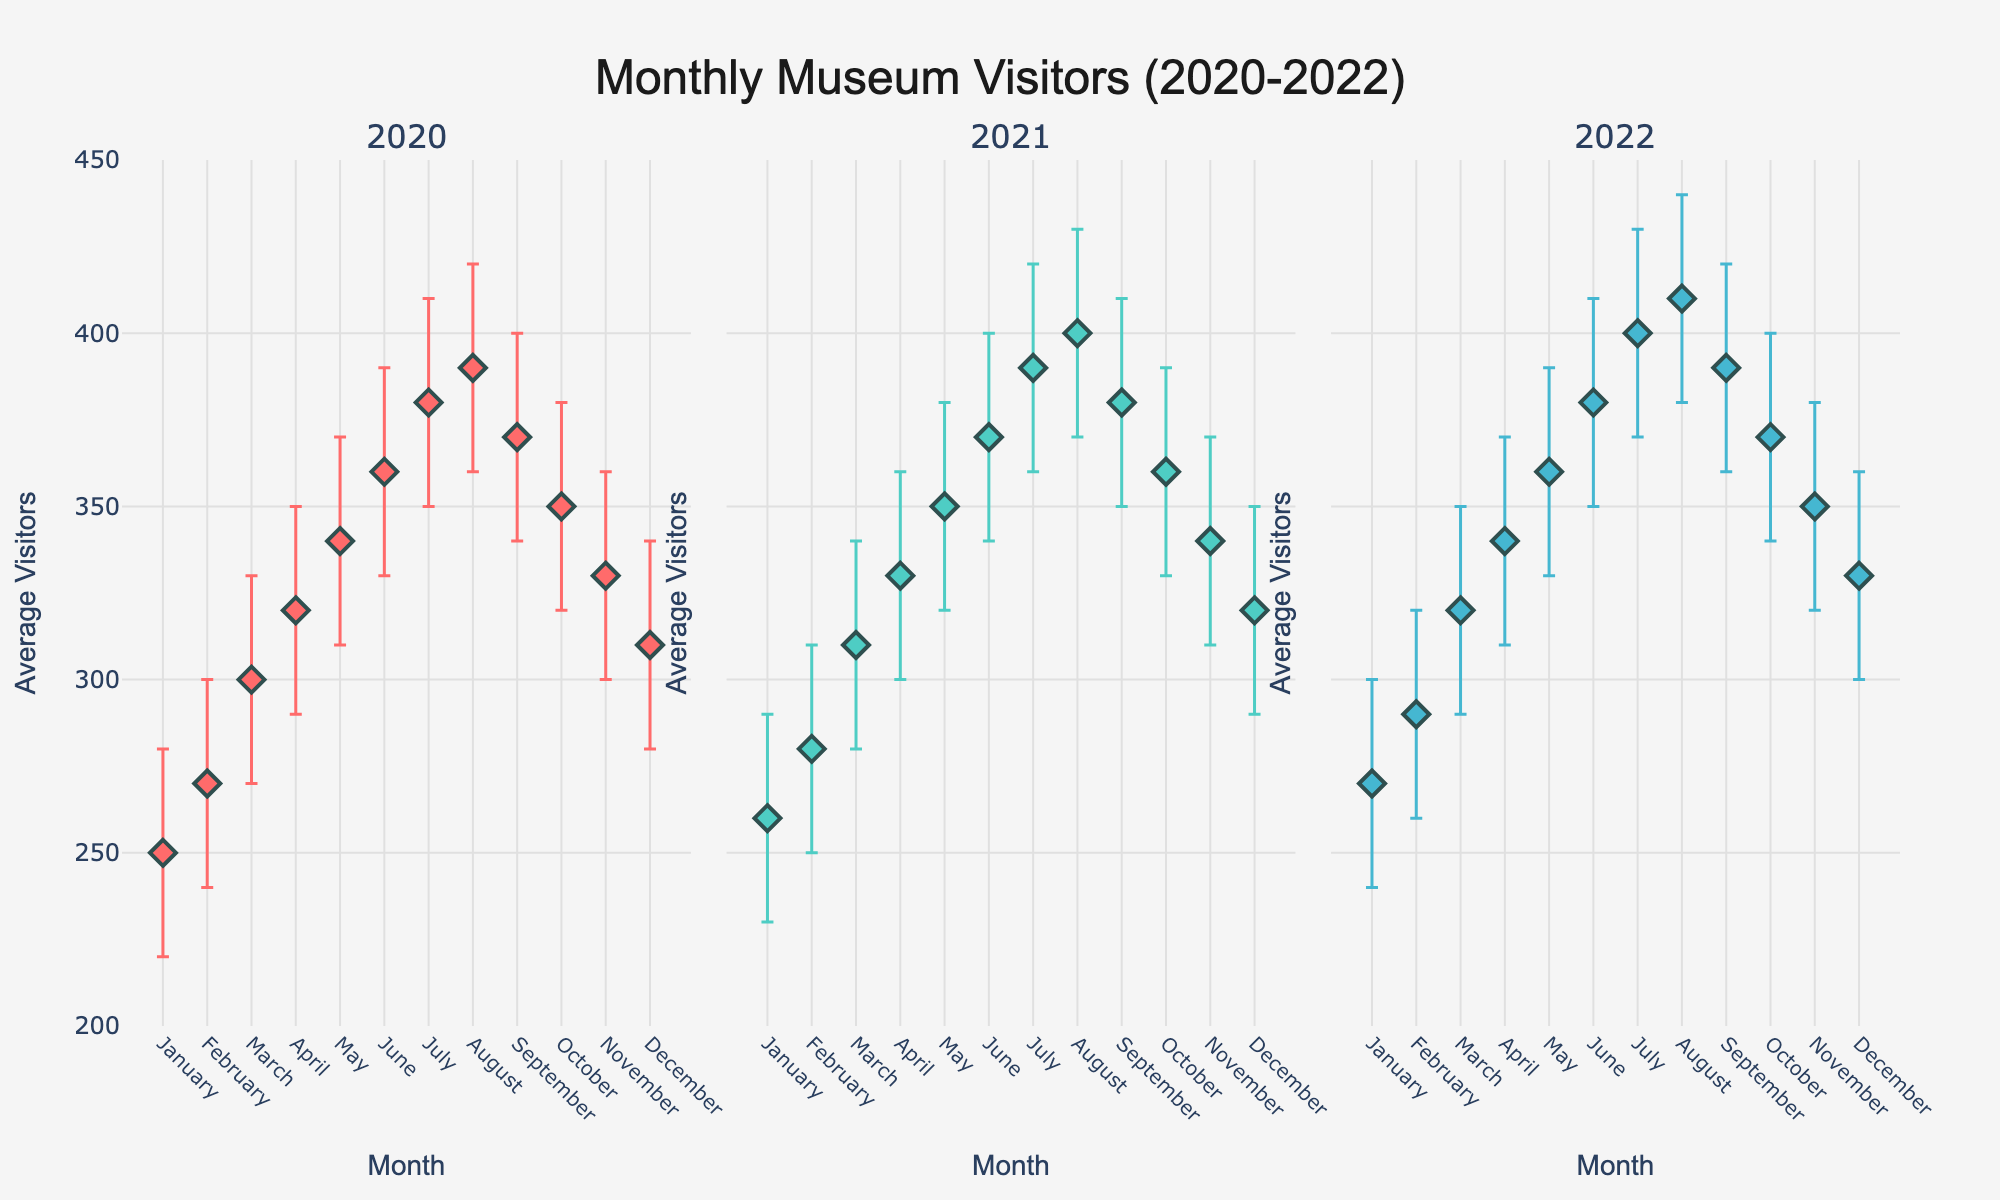How many months are shown for the year 2021? The plot has subplots for each year from 2020 to 2022, and each subplot lists the months from January to December. Therefore, there are 12 months shown for the year 2021.
Answer: 12 What is the title of the figure? The title of the figure is clearly displayed at the top and reads, "Monthly Museum Visitors (2020-2022)".
Answer: Monthly Museum Visitors (2020-2022) Which year had the lowest average visitors in January? By observing the data points with error bars for January in each subplot, the year with the lowest average visitors (260) is 2021.
Answer: 2021 Which month had the highest average visitor count in 2022? By looking at the subplot for the year 2022, we can see that August had the highest average visitor count (410).
Answer: August Compare the average visitors in July across the three years. Which year had the most visitors? Looking at the data points for July in each subplot, 2022 had the highest average visitors (400), followed by 2021 (390) and 2020 (380).
Answer: 2022 How much did the average visitor count change from the highest month to the lowest month in 2020? The highest average visitor count in 2020 was in August (390) and the lowest was in January (250). The change is 390 - 250 = 140.
Answer: 140 Which month in 2021 showed the smallest confidence interval? By observing the length of the error bars in the 2021 subplot, April has the smallest confidence interval, as the error bars are the shortest.
Answer: April What trend can you observe about the average number of visitors from January to December in 2022? In 2022, there's an overall increasing trend from January to August, followed by a decreasing trend from September to December.
Answer: Increasing then decreasing In which year did October have a higher visitor average - 2020 or 2022? By comparing the October average visitor counts in the subplots, 2022 (370) had a higher visitor average than 2020 (350).
Answer: 2022 What pattern can be seen in the visitor numbers over the years from January to December for any year? Generally, there is an increasing trend from January to the middle of the year around August, followed by a decrease towards December for all three years.
Answer: Increasing then decreasing 